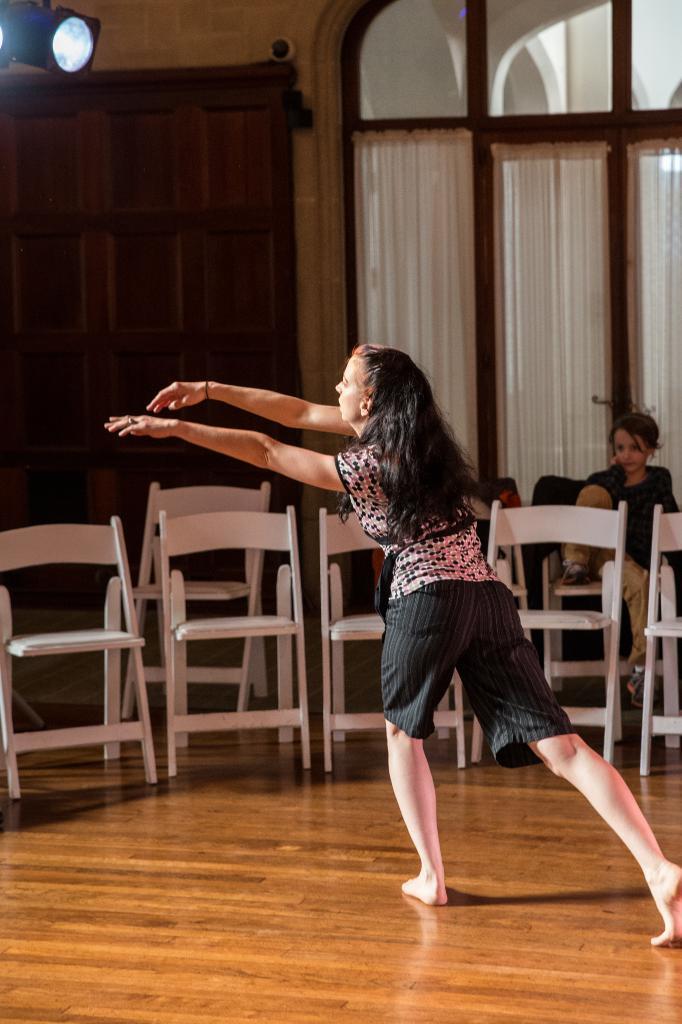How would you summarize this image in a sentence or two? This woman is dancing, as there is a movement in her hands and legs. We can able to see chairs. On top there is a focusing light. This woman is sitting on a chair. This is door. This is a window with curtain. 